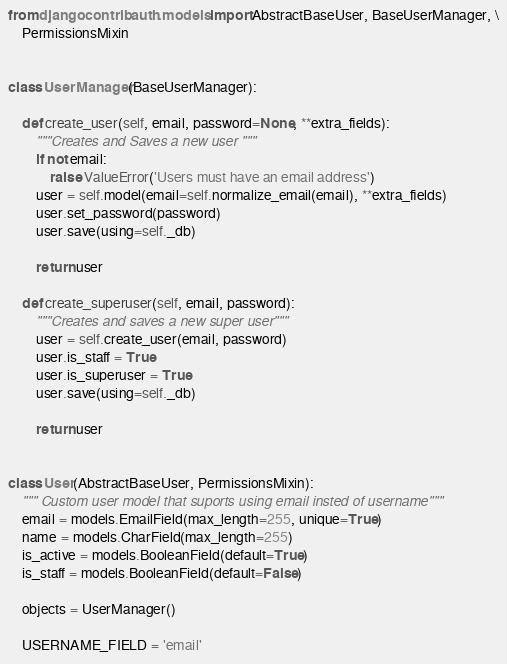Convert code to text. <code><loc_0><loc_0><loc_500><loc_500><_Python_>from django.contrib.auth.models import AbstractBaseUser, BaseUserManager, \
    PermissionsMixin


class UserManager(BaseUserManager):

    def create_user(self, email, password=None, **extra_fields):
        """Creates and Saves a new user """
        if not email:
            raise ValueError('Users must have an email address')
        user = self.model(email=self.normalize_email(email), **extra_fields)
        user.set_password(password)
        user.save(using=self._db)

        return user

    def create_superuser(self, email, password):
        """Creates and saves a new super user"""
        user = self.create_user(email, password)
        user.is_staff = True
        user.is_superuser = True
        user.save(using=self._db)

        return user


class User(AbstractBaseUser, PermissionsMixin):
    """ Custom user model that suports using email insted of username"""
    email = models.EmailField(max_length=255, unique=True)
    name = models.CharField(max_length=255)
    is_active = models.BooleanField(default=True)
    is_staff = models.BooleanField(default=False)

    objects = UserManager()

    USERNAME_FIELD = 'email'
</code> 